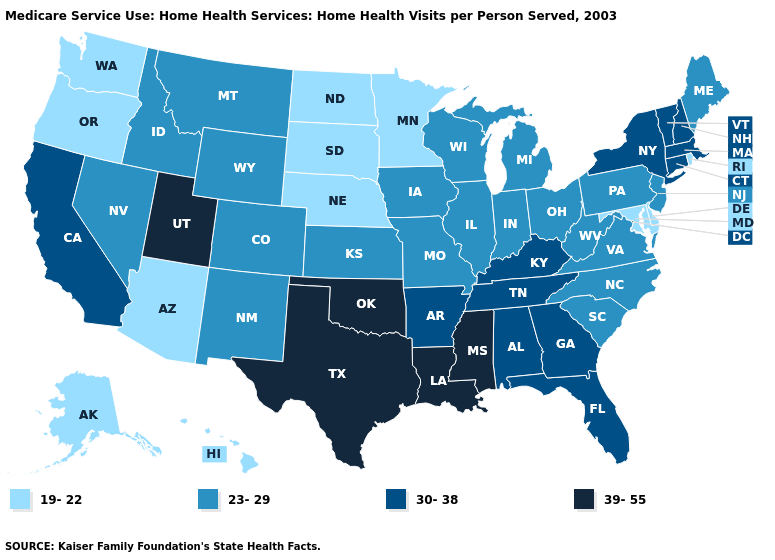Among the states that border Maryland , does Virginia have the highest value?
Answer briefly. Yes. Does the first symbol in the legend represent the smallest category?
Short answer required. Yes. What is the value of Alabama?
Short answer required. 30-38. What is the value of Delaware?
Be succinct. 19-22. Name the states that have a value in the range 39-55?
Concise answer only. Louisiana, Mississippi, Oklahoma, Texas, Utah. Is the legend a continuous bar?
Write a very short answer. No. Name the states that have a value in the range 39-55?
Concise answer only. Louisiana, Mississippi, Oklahoma, Texas, Utah. What is the lowest value in the USA?
Be succinct. 19-22. Is the legend a continuous bar?
Short answer required. No. Which states hav the highest value in the MidWest?
Write a very short answer. Illinois, Indiana, Iowa, Kansas, Michigan, Missouri, Ohio, Wisconsin. Name the states that have a value in the range 30-38?
Short answer required. Alabama, Arkansas, California, Connecticut, Florida, Georgia, Kentucky, Massachusetts, New Hampshire, New York, Tennessee, Vermont. Which states have the lowest value in the USA?
Write a very short answer. Alaska, Arizona, Delaware, Hawaii, Maryland, Minnesota, Nebraska, North Dakota, Oregon, Rhode Island, South Dakota, Washington. What is the lowest value in states that border Texas?
Short answer required. 23-29. Does Michigan have a higher value than Arizona?
Write a very short answer. Yes. Which states have the highest value in the USA?
Short answer required. Louisiana, Mississippi, Oklahoma, Texas, Utah. 